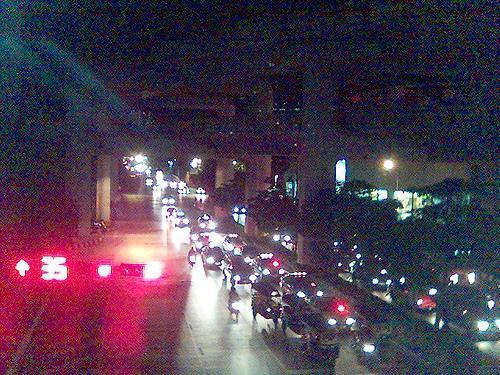How many cows are standing?
Give a very brief answer. 0. 